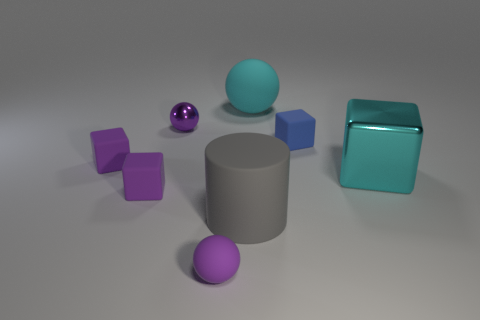Add 2 blue objects. How many objects exist? 10 Subtract all cylinders. How many objects are left? 7 Add 5 large cyan blocks. How many large cyan blocks are left? 6 Add 5 small shiny spheres. How many small shiny spheres exist? 6 Subtract 0 yellow balls. How many objects are left? 8 Subtract all small blue matte blocks. Subtract all yellow shiny blocks. How many objects are left? 7 